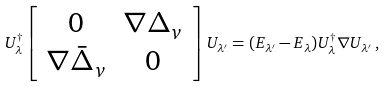Convert formula to latex. <formula><loc_0><loc_0><loc_500><loc_500>U ^ { \dagger } _ { \lambda } \left [ \begin{array} { c c } 0 & { \nabla } \Delta _ { v } \\ { \nabla } \bar { \Delta } _ { v } & 0 \end{array} \right ] U _ { \lambda ^ { \prime } } = ( E _ { \lambda ^ { \prime } } - E _ { \lambda } ) U ^ { \dagger } _ { \lambda } { \nabla } U _ { \lambda ^ { \prime } } \, ,</formula> 